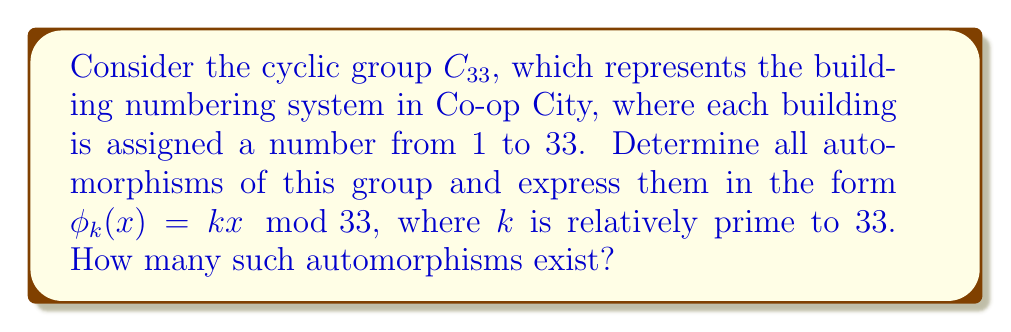Can you answer this question? To solve this problem, we need to follow these steps:

1) First, recall that for a cyclic group $C_n$, all automorphisms are of the form $\phi_k(x) = kx \mod n$, where $k$ is relatively prime to $n$.

2) In this case, $n = 33$. So we need to find all values of $k$ between 1 and 32 that are relatively prime to 33.

3) To be relatively prime to 33, $k$ must not share any common factors with 33. The factors of 33 are 1, 3, 11, and 33.

4) We can list out all numbers from 1 to 32 that are not divisible by 3 or 11:

   1, 2, 4, 5, 7, 8, 10, 13, 14, 16, 17, 19, 20, 23, 25, 26, 28, 29, 31, 32

5) These 20 numbers represent all possible values for $k$ that will generate an automorphism of $C_{33}$.

6) Therefore, there are 20 distinct automorphisms of $C_{33}$, each of the form $\phi_k(x) = kx \mod 33$, where $k$ is one of the numbers listed in step 4.

7) The number of automorphisms is equal to $\phi(33)$, where $\phi$ is Euler's totient function. This is because $\phi(n)$ counts the numbers up to $n$ that are relatively prime to $n$.

8) We can verify: $\phi(33) = \phi(3) \cdot \phi(11) = 2 \cdot 10 = 20$, which matches our count.
Answer: There are 20 automorphisms of $C_{33}$, each of the form $\phi_k(x) = kx \mod 33$, where $k \in \{1, 2, 4, 5, 7, 8, 10, 13, 14, 16, 17, 19, 20, 23, 25, 26, 28, 29, 31, 32\}$. 